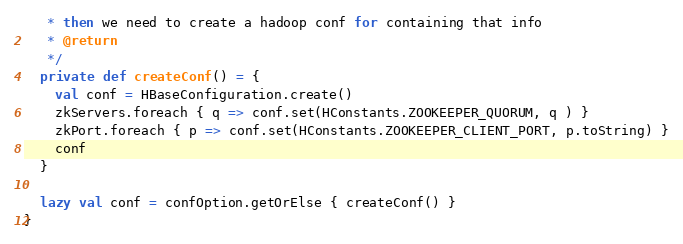<code> <loc_0><loc_0><loc_500><loc_500><_Scala_>   * then we need to create a hadoop conf for containing that info
   * @return
   */
  private def createConf() = {
    val conf = HBaseConfiguration.create()
    zkServers.foreach { q => conf.set(HConstants.ZOOKEEPER_QUORUM, q ) }
    zkPort.foreach { p => conf.set(HConstants.ZOOKEEPER_CLIENT_PORT, p.toString) }
    conf
  }

  lazy val conf = confOption.getOrElse { createConf() }
}
</code> 